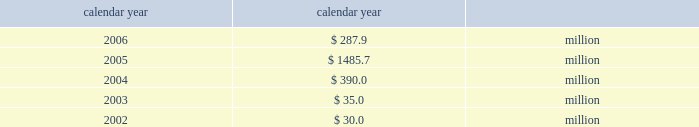Taxes .
If group or its bermuda subsidiaries were to become subject to u.s .
Income tax ; there could be a material adverse effect on the company 2019s financial condition , results of operations and cash flows .
United kingdom .
Bermuda re 2019s uk branch conducts business in the uk and is subject to taxation in the uk .
Bermuda re believes that it has operated and will continue to operate its bermuda operation in a manner which will not cause them to be subject to uk taxation .
If bermuda re 2019s bermuda operations were to become subject to uk income tax there could be a material adverse impact on the company 2019s financial condition , results of operations and cash flow .
Available information the company 2019s annual reports on form 10-k , quarterly reports on form 10-q , current reports on form 8-k , proxy state- ments and amendments to those reports are available free of charge through the company 2019s internet website at http://www.everestre.com as soon as reasonably practicable after such reports are electronically filed with the securities and exchange commission ( the 201csec 201d ) .
I t e m 1 a .
R i s k f a c t o r s in addition to the other information provided in this report , the following risk factors should be considered when evaluating an investment in our securities .
If the circumstances contemplated by the individual risk factors materialize , our business , finan- cial condition and results of operations could be materially and adversely affected and the trading price of our common shares could decline significantly .
R i s k s r e l a t i n g t o o u r b u s i n e s s our results could be adversely affected by catastrophic events .
We are exposed to unpredictable catastrophic events , including weather-related and other natural catastrophes , as well as acts of terrorism .
Any material reduction in our operating results caused by the occurrence of one or more catastrophes could inhibit our ability to pay dividends or to meet our interest and principal payment obligations .
We define a catastrophe as an event that causes a pre-tax loss on property exposures before reinsurance of at least $ 5.0 million , before corporate level rein- surance and taxes .
Effective for the third quarter 2005 , industrial risk losses have been excluded from catastrophe losses , with prior periods adjusted for comparison purposes .
By way of illustration , during the past five calendar years , pre-tax catastrophe losses , net of contract specific reinsurance but before cessions under corporate reinsurance programs , were as follows: .
Our losses from future catastrophic events could exceed our projections .
We use projections of possible losses from future catastrophic events of varying types and magnitudes as a strategic under- writing tool .
We use these loss projections to estimate our potential catastrophe losses in certain geographic areas and decide on the purchase of retrocessional coverage or other actions to limit the extent of potential losses in a given geographic area .
These loss projections are approximations reliant on a mix of quantitative and qualitative processes and actual losses may exceed the projections by a material amount .
We focus on potential losses that can be generated by any single event as part of our evaluation and monitoring of our aggre- gate exposure to catastrophic events .
Accordingly , we employ various techniques to estimate the amount of loss we could sustain from any single catastrophic event in various geographical areas .
These techniques range from non-modeled deterministic approaches 2014such as tracking aggregate limits exposed in catastrophe-prone zones and applying historic dam- age factors 2014to modeled approaches that scientifically measure catastrophe risks using sophisticated monte carlo simulation techniques that provide insights into the frequency and severity of expected losses on a probabilistic basis .
If our loss reserves are inadequate to meet our actual losses , net income would be reduced or we could incur a loss .
We are required to maintain reserves to cover our estimated ultimate liability of losses and loss adjustment expenses for both reported and unreported claims incurred .
These reserves are only estimates of what we believe the settlement and adminis- tration of claims will cost based on facts and circumstances known to us .
In setting reserves for our reinsurance liabilities , we rely on claim data supplied by our ceding companies and brokers and we employ actuarial and statistical projections .
The information received from our ceding companies is not always timely or accurate , which can contribute to inaccuracies in our 81790fin_a 4/13/07 11:08 am page 23 http://www.everestre.com .
What are the total pre-tax catastrophe losses in the three two years? 
Computations: ((287.9 + 1485.7) + 390.0)
Answer: 2163.6. 